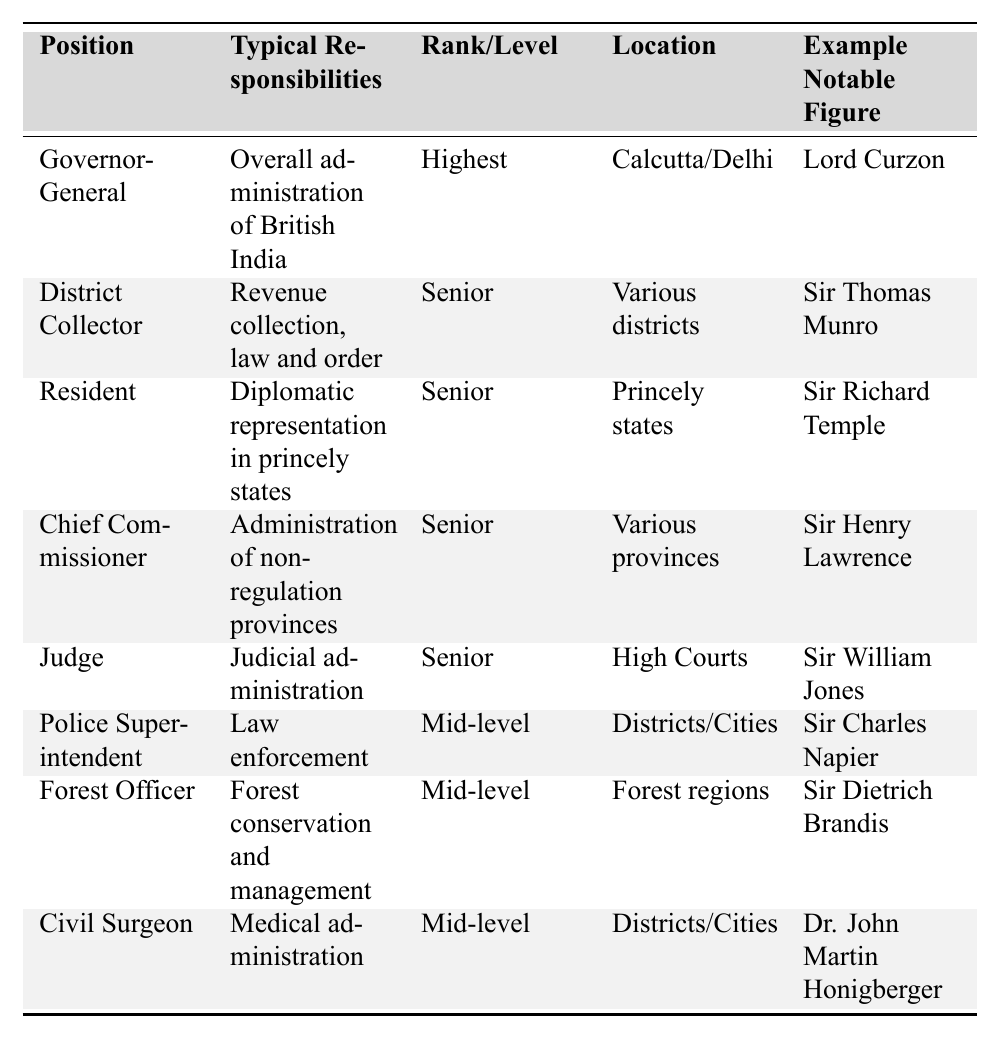What is the highest rank position listed in the table? The highest rank position is indicated in the "Rank/Level" column for each entry. Scanning the list, "Governor-General" is marked as the "Highest" rank.
Answer: Governor-General Who is the notable figure associated with the Chief Commissioner position? To find this, we look at the "Chief Commissioner" row and read the corresponding "Example Notable Figure" column, which lists "Sir Henry Lawrence."
Answer: Sir Henry Lawrence How many positions are categorized as 'Mid-level'? By reviewing the "Rank/Level" column, we can count the positions labeled "Mid-level." There are three such positions: Police Superintendent, Forest Officer, and Civil Surgeon.
Answer: 3 Is the Resident position responsible for judicial administration? To answer this, we check the "Typical Responsibilities" for the Resident position, which is "Diplomatic representation in princely states." This shows it's not responsible for judicial administration.
Answer: No Which notable figure is linked to the role of District Collector? We check the row for District Collector and read the corresponding entry in the "Example Notable Figure" column, which lists "Sir Thomas Munro."
Answer: Sir Thomas Munro What responsibilities does the Police Superintendent position include? The "Typical Responsibilities" for the Police Superintendent is listed under its row, where it states "Law enforcement."
Answer: Law enforcement How does the number of Senior positions compare to Mid-level positions? There are four Senior positions: Governor-General, District Collector, Resident, Chief Commissioner, and Judge. Plus, we have three Mid-level positions as counted earlier. So, 4 (Senior) versus 3 (Mid-level) indicates more Senior roles.
Answer: More Senior positions Where is the Forest Officer typically located? We refer to the "Location" column for the Forest Officer entry, which specifies "Forest regions."
Answer: Forest regions Which position has responsibilities related to medical administration? A quick look at the "Typical Responsibilities" shows that the "Civil Surgeon" is identified for "Medical administration."
Answer: Civil Surgeon What is the difference in rank levels between the Governor-General and the Judge? The Governor-General ranks as "Highest," while the Judge is categorized as "Senior." Thus, the difference between "Highest" and "Senior" is that one is at the top and the other is a step below.
Answer: One rank lower 